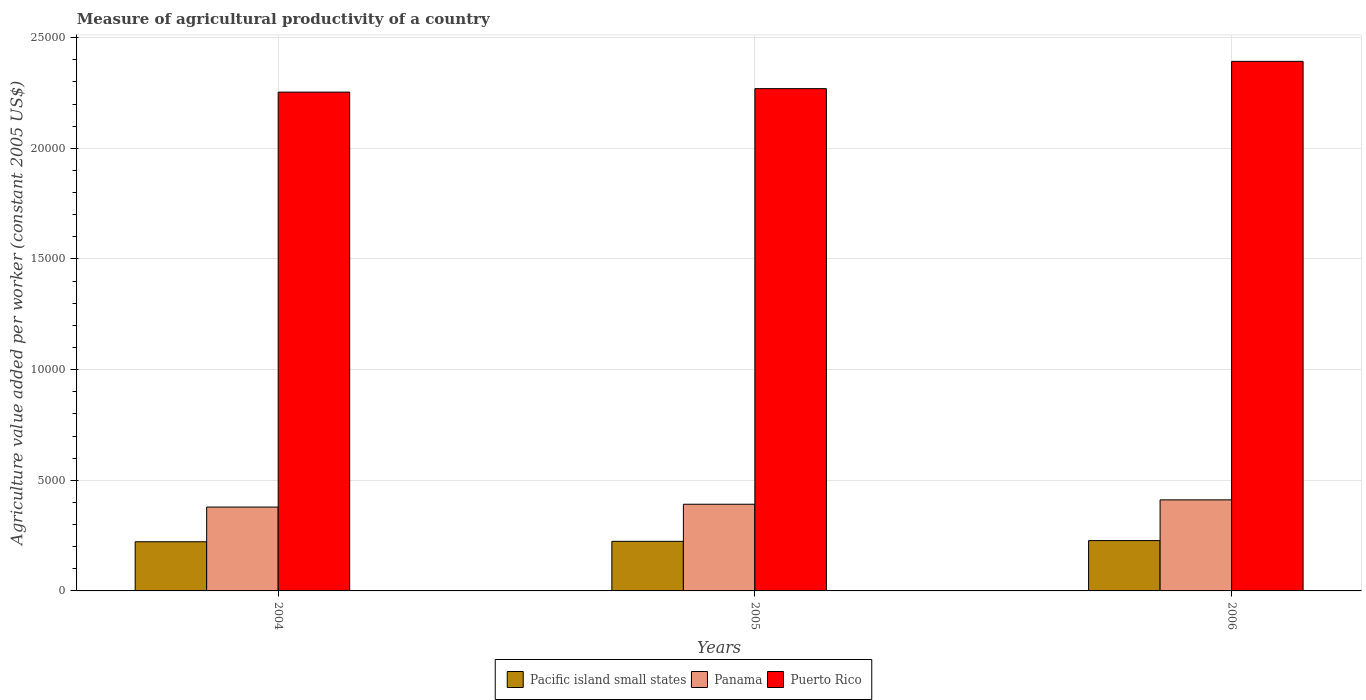How many groups of bars are there?
Ensure brevity in your answer.  3. Are the number of bars per tick equal to the number of legend labels?
Ensure brevity in your answer.  Yes. Are the number of bars on each tick of the X-axis equal?
Make the answer very short. Yes. How many bars are there on the 1st tick from the left?
Keep it short and to the point. 3. How many bars are there on the 3rd tick from the right?
Give a very brief answer. 3. What is the label of the 1st group of bars from the left?
Offer a very short reply. 2004. What is the measure of agricultural productivity in Panama in 2006?
Make the answer very short. 4114.14. Across all years, what is the maximum measure of agricultural productivity in Panama?
Your answer should be very brief. 4114.14. Across all years, what is the minimum measure of agricultural productivity in Panama?
Offer a terse response. 3788.64. In which year was the measure of agricultural productivity in Puerto Rico maximum?
Your answer should be compact. 2006. In which year was the measure of agricultural productivity in Pacific island small states minimum?
Your answer should be compact. 2004. What is the total measure of agricultural productivity in Pacific island small states in the graph?
Provide a short and direct response. 6736.18. What is the difference between the measure of agricultural productivity in Puerto Rico in 2004 and that in 2005?
Give a very brief answer. -157.61. What is the difference between the measure of agricultural productivity in Pacific island small states in 2005 and the measure of agricultural productivity in Panama in 2006?
Your answer should be very brief. -1873.36. What is the average measure of agricultural productivity in Pacific island small states per year?
Offer a very short reply. 2245.39. In the year 2005, what is the difference between the measure of agricultural productivity in Pacific island small states and measure of agricultural productivity in Puerto Rico?
Offer a very short reply. -2.05e+04. In how many years, is the measure of agricultural productivity in Panama greater than 19000 US$?
Your answer should be very brief. 0. What is the ratio of the measure of agricultural productivity in Puerto Rico in 2005 to that in 2006?
Provide a short and direct response. 0.95. Is the measure of agricultural productivity in Puerto Rico in 2005 less than that in 2006?
Your answer should be very brief. Yes. Is the difference between the measure of agricultural productivity in Pacific island small states in 2005 and 2006 greater than the difference between the measure of agricultural productivity in Puerto Rico in 2005 and 2006?
Keep it short and to the point. Yes. What is the difference between the highest and the second highest measure of agricultural productivity in Panama?
Offer a very short reply. 197.41. What is the difference between the highest and the lowest measure of agricultural productivity in Puerto Rico?
Give a very brief answer. 1390.75. In how many years, is the measure of agricultural productivity in Pacific island small states greater than the average measure of agricultural productivity in Pacific island small states taken over all years?
Make the answer very short. 1. What does the 2nd bar from the left in 2005 represents?
Provide a short and direct response. Panama. What does the 3rd bar from the right in 2004 represents?
Offer a terse response. Pacific island small states. Is it the case that in every year, the sum of the measure of agricultural productivity in Puerto Rico and measure of agricultural productivity in Pacific island small states is greater than the measure of agricultural productivity in Panama?
Provide a short and direct response. Yes. How many years are there in the graph?
Provide a succinct answer. 3. Does the graph contain any zero values?
Provide a short and direct response. No. Does the graph contain grids?
Make the answer very short. Yes. What is the title of the graph?
Give a very brief answer. Measure of agricultural productivity of a country. Does "Vietnam" appear as one of the legend labels in the graph?
Your answer should be compact. No. What is the label or title of the X-axis?
Give a very brief answer. Years. What is the label or title of the Y-axis?
Ensure brevity in your answer.  Agriculture value added per worker (constant 2005 US$). What is the Agriculture value added per worker (constant 2005 US$) in Pacific island small states in 2004?
Provide a succinct answer. 2221.59. What is the Agriculture value added per worker (constant 2005 US$) of Panama in 2004?
Your answer should be very brief. 3788.64. What is the Agriculture value added per worker (constant 2005 US$) of Puerto Rico in 2004?
Give a very brief answer. 2.25e+04. What is the Agriculture value added per worker (constant 2005 US$) in Pacific island small states in 2005?
Offer a very short reply. 2240.78. What is the Agriculture value added per worker (constant 2005 US$) of Panama in 2005?
Your answer should be compact. 3916.73. What is the Agriculture value added per worker (constant 2005 US$) in Puerto Rico in 2005?
Your answer should be very brief. 2.27e+04. What is the Agriculture value added per worker (constant 2005 US$) of Pacific island small states in 2006?
Your answer should be compact. 2273.81. What is the Agriculture value added per worker (constant 2005 US$) in Panama in 2006?
Keep it short and to the point. 4114.14. What is the Agriculture value added per worker (constant 2005 US$) in Puerto Rico in 2006?
Provide a succinct answer. 2.39e+04. Across all years, what is the maximum Agriculture value added per worker (constant 2005 US$) in Pacific island small states?
Ensure brevity in your answer.  2273.81. Across all years, what is the maximum Agriculture value added per worker (constant 2005 US$) of Panama?
Your answer should be compact. 4114.14. Across all years, what is the maximum Agriculture value added per worker (constant 2005 US$) of Puerto Rico?
Ensure brevity in your answer.  2.39e+04. Across all years, what is the minimum Agriculture value added per worker (constant 2005 US$) of Pacific island small states?
Your answer should be very brief. 2221.59. Across all years, what is the minimum Agriculture value added per worker (constant 2005 US$) in Panama?
Keep it short and to the point. 3788.64. Across all years, what is the minimum Agriculture value added per worker (constant 2005 US$) of Puerto Rico?
Provide a short and direct response. 2.25e+04. What is the total Agriculture value added per worker (constant 2005 US$) of Pacific island small states in the graph?
Keep it short and to the point. 6736.18. What is the total Agriculture value added per worker (constant 2005 US$) in Panama in the graph?
Provide a succinct answer. 1.18e+04. What is the total Agriculture value added per worker (constant 2005 US$) of Puerto Rico in the graph?
Give a very brief answer. 6.92e+04. What is the difference between the Agriculture value added per worker (constant 2005 US$) in Pacific island small states in 2004 and that in 2005?
Keep it short and to the point. -19.2. What is the difference between the Agriculture value added per worker (constant 2005 US$) in Panama in 2004 and that in 2005?
Provide a short and direct response. -128.09. What is the difference between the Agriculture value added per worker (constant 2005 US$) in Puerto Rico in 2004 and that in 2005?
Keep it short and to the point. -157.61. What is the difference between the Agriculture value added per worker (constant 2005 US$) in Pacific island small states in 2004 and that in 2006?
Your answer should be compact. -52.22. What is the difference between the Agriculture value added per worker (constant 2005 US$) of Panama in 2004 and that in 2006?
Keep it short and to the point. -325.5. What is the difference between the Agriculture value added per worker (constant 2005 US$) in Puerto Rico in 2004 and that in 2006?
Your answer should be compact. -1390.75. What is the difference between the Agriculture value added per worker (constant 2005 US$) in Pacific island small states in 2005 and that in 2006?
Provide a succinct answer. -33.02. What is the difference between the Agriculture value added per worker (constant 2005 US$) of Panama in 2005 and that in 2006?
Your response must be concise. -197.41. What is the difference between the Agriculture value added per worker (constant 2005 US$) of Puerto Rico in 2005 and that in 2006?
Keep it short and to the point. -1233.15. What is the difference between the Agriculture value added per worker (constant 2005 US$) of Pacific island small states in 2004 and the Agriculture value added per worker (constant 2005 US$) of Panama in 2005?
Give a very brief answer. -1695.14. What is the difference between the Agriculture value added per worker (constant 2005 US$) in Pacific island small states in 2004 and the Agriculture value added per worker (constant 2005 US$) in Puerto Rico in 2005?
Provide a short and direct response. -2.05e+04. What is the difference between the Agriculture value added per worker (constant 2005 US$) of Panama in 2004 and the Agriculture value added per worker (constant 2005 US$) of Puerto Rico in 2005?
Make the answer very short. -1.89e+04. What is the difference between the Agriculture value added per worker (constant 2005 US$) in Pacific island small states in 2004 and the Agriculture value added per worker (constant 2005 US$) in Panama in 2006?
Your answer should be very brief. -1892.55. What is the difference between the Agriculture value added per worker (constant 2005 US$) in Pacific island small states in 2004 and the Agriculture value added per worker (constant 2005 US$) in Puerto Rico in 2006?
Offer a very short reply. -2.17e+04. What is the difference between the Agriculture value added per worker (constant 2005 US$) in Panama in 2004 and the Agriculture value added per worker (constant 2005 US$) in Puerto Rico in 2006?
Make the answer very short. -2.01e+04. What is the difference between the Agriculture value added per worker (constant 2005 US$) in Pacific island small states in 2005 and the Agriculture value added per worker (constant 2005 US$) in Panama in 2006?
Your answer should be compact. -1873.36. What is the difference between the Agriculture value added per worker (constant 2005 US$) in Pacific island small states in 2005 and the Agriculture value added per worker (constant 2005 US$) in Puerto Rico in 2006?
Your answer should be compact. -2.17e+04. What is the difference between the Agriculture value added per worker (constant 2005 US$) of Panama in 2005 and the Agriculture value added per worker (constant 2005 US$) of Puerto Rico in 2006?
Provide a short and direct response. -2.00e+04. What is the average Agriculture value added per worker (constant 2005 US$) of Pacific island small states per year?
Offer a terse response. 2245.39. What is the average Agriculture value added per worker (constant 2005 US$) of Panama per year?
Your response must be concise. 3939.84. What is the average Agriculture value added per worker (constant 2005 US$) of Puerto Rico per year?
Offer a very short reply. 2.31e+04. In the year 2004, what is the difference between the Agriculture value added per worker (constant 2005 US$) of Pacific island small states and Agriculture value added per worker (constant 2005 US$) of Panama?
Keep it short and to the point. -1567.05. In the year 2004, what is the difference between the Agriculture value added per worker (constant 2005 US$) of Pacific island small states and Agriculture value added per worker (constant 2005 US$) of Puerto Rico?
Keep it short and to the point. -2.03e+04. In the year 2004, what is the difference between the Agriculture value added per worker (constant 2005 US$) in Panama and Agriculture value added per worker (constant 2005 US$) in Puerto Rico?
Provide a succinct answer. -1.87e+04. In the year 2005, what is the difference between the Agriculture value added per worker (constant 2005 US$) in Pacific island small states and Agriculture value added per worker (constant 2005 US$) in Panama?
Offer a very short reply. -1675.95. In the year 2005, what is the difference between the Agriculture value added per worker (constant 2005 US$) in Pacific island small states and Agriculture value added per worker (constant 2005 US$) in Puerto Rico?
Provide a succinct answer. -2.05e+04. In the year 2005, what is the difference between the Agriculture value added per worker (constant 2005 US$) of Panama and Agriculture value added per worker (constant 2005 US$) of Puerto Rico?
Keep it short and to the point. -1.88e+04. In the year 2006, what is the difference between the Agriculture value added per worker (constant 2005 US$) of Pacific island small states and Agriculture value added per worker (constant 2005 US$) of Panama?
Keep it short and to the point. -1840.33. In the year 2006, what is the difference between the Agriculture value added per worker (constant 2005 US$) of Pacific island small states and Agriculture value added per worker (constant 2005 US$) of Puerto Rico?
Your response must be concise. -2.17e+04. In the year 2006, what is the difference between the Agriculture value added per worker (constant 2005 US$) in Panama and Agriculture value added per worker (constant 2005 US$) in Puerto Rico?
Provide a short and direct response. -1.98e+04. What is the ratio of the Agriculture value added per worker (constant 2005 US$) in Pacific island small states in 2004 to that in 2005?
Your response must be concise. 0.99. What is the ratio of the Agriculture value added per worker (constant 2005 US$) of Panama in 2004 to that in 2005?
Offer a very short reply. 0.97. What is the ratio of the Agriculture value added per worker (constant 2005 US$) in Panama in 2004 to that in 2006?
Provide a short and direct response. 0.92. What is the ratio of the Agriculture value added per worker (constant 2005 US$) in Puerto Rico in 2004 to that in 2006?
Your answer should be very brief. 0.94. What is the ratio of the Agriculture value added per worker (constant 2005 US$) in Pacific island small states in 2005 to that in 2006?
Your response must be concise. 0.99. What is the ratio of the Agriculture value added per worker (constant 2005 US$) of Puerto Rico in 2005 to that in 2006?
Ensure brevity in your answer.  0.95. What is the difference between the highest and the second highest Agriculture value added per worker (constant 2005 US$) in Pacific island small states?
Ensure brevity in your answer.  33.02. What is the difference between the highest and the second highest Agriculture value added per worker (constant 2005 US$) of Panama?
Provide a short and direct response. 197.41. What is the difference between the highest and the second highest Agriculture value added per worker (constant 2005 US$) in Puerto Rico?
Offer a very short reply. 1233.15. What is the difference between the highest and the lowest Agriculture value added per worker (constant 2005 US$) of Pacific island small states?
Give a very brief answer. 52.22. What is the difference between the highest and the lowest Agriculture value added per worker (constant 2005 US$) of Panama?
Your response must be concise. 325.5. What is the difference between the highest and the lowest Agriculture value added per worker (constant 2005 US$) in Puerto Rico?
Keep it short and to the point. 1390.75. 